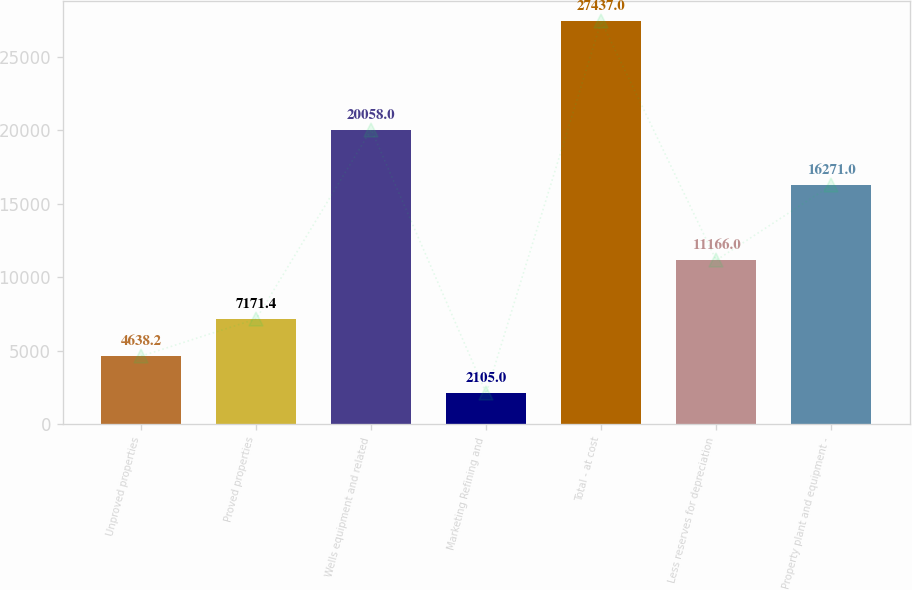Convert chart to OTSL. <chart><loc_0><loc_0><loc_500><loc_500><bar_chart><fcel>Unproved properties<fcel>Proved properties<fcel>Wells equipment and related<fcel>Marketing Refining and<fcel>Total - at cost<fcel>Less reserves for depreciation<fcel>Property plant and equipment -<nl><fcel>4638.2<fcel>7171.4<fcel>20058<fcel>2105<fcel>27437<fcel>11166<fcel>16271<nl></chart> 